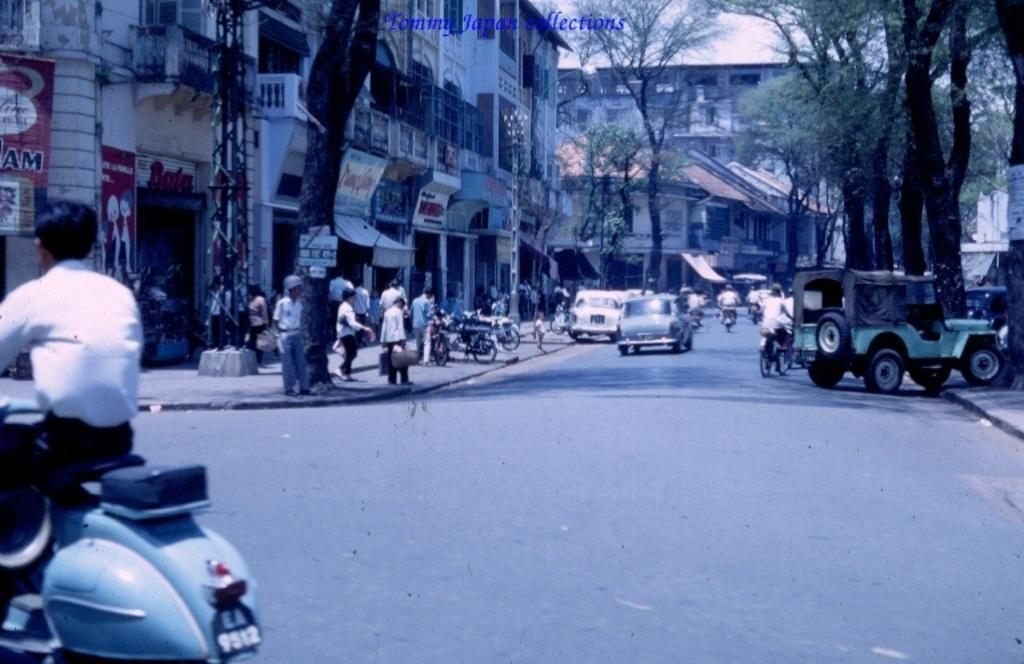What is on the left side of the image? There is a person on a bike on the left side of the image. What can be seen in the background of the image? In the background of the image, there are people, posters, stalls, buildings, poles, vehicles, trees, and the sky. How many elements can be identified in the background of the image? There are nine elements identifiable in the background of the image. What type of unit is being carried by the person on the bike in the image? There is no unit visible in the image; the person on the bike is not carrying anything. How many hands are visible in the image? The number of hands visible in the image cannot be determined from the provided facts. Is there a kite flying in the sky in the image? There is no mention of a kite in the image, so it cannot be determined if one is present. 